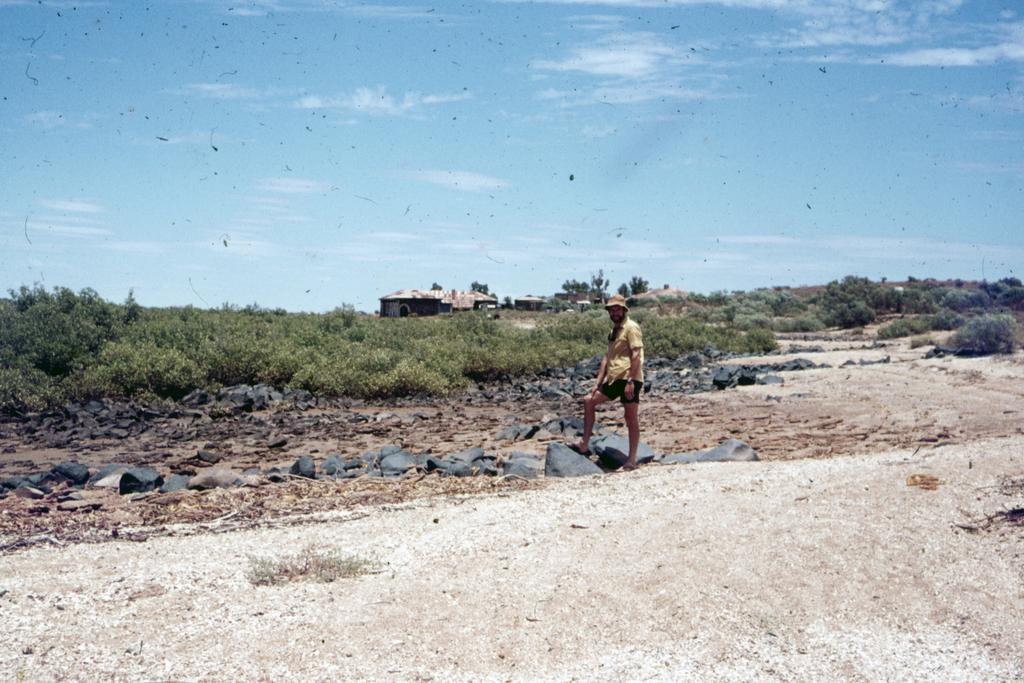Please provide a concise description of this image. In front of the image there is a person standing by placing his leg on a rock, behind the person there are rocks, trees and bushes, in the background of the image there are wooden houses, at the top of the image there are clouds in the sky. 